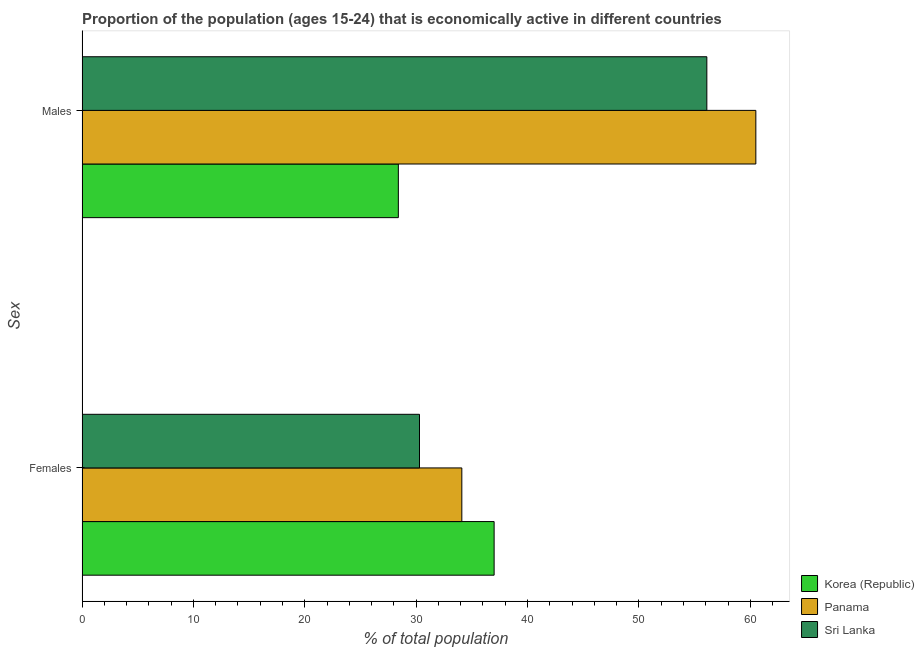How many different coloured bars are there?
Provide a short and direct response. 3. How many groups of bars are there?
Your response must be concise. 2. Are the number of bars per tick equal to the number of legend labels?
Make the answer very short. Yes. How many bars are there on the 1st tick from the top?
Offer a terse response. 3. What is the label of the 1st group of bars from the top?
Provide a succinct answer. Males. What is the percentage of economically active male population in Panama?
Your answer should be compact. 60.5. Across all countries, what is the maximum percentage of economically active female population?
Give a very brief answer. 37. Across all countries, what is the minimum percentage of economically active female population?
Your response must be concise. 30.3. In which country was the percentage of economically active male population maximum?
Keep it short and to the point. Panama. In which country was the percentage of economically active female population minimum?
Ensure brevity in your answer.  Sri Lanka. What is the total percentage of economically active female population in the graph?
Ensure brevity in your answer.  101.4. What is the difference between the percentage of economically active male population in Panama and that in Korea (Republic)?
Offer a terse response. 32.1. What is the difference between the percentage of economically active male population in Panama and the percentage of economically active female population in Sri Lanka?
Make the answer very short. 30.2. What is the average percentage of economically active female population per country?
Provide a succinct answer. 33.8. What is the difference between the percentage of economically active male population and percentage of economically active female population in Sri Lanka?
Keep it short and to the point. 25.8. What is the ratio of the percentage of economically active female population in Panama to that in Korea (Republic)?
Offer a terse response. 0.92. Is the percentage of economically active male population in Korea (Republic) less than that in Sri Lanka?
Provide a succinct answer. Yes. What does the 3rd bar from the top in Males represents?
Give a very brief answer. Korea (Republic). What does the 3rd bar from the bottom in Females represents?
Your answer should be very brief. Sri Lanka. Are the values on the major ticks of X-axis written in scientific E-notation?
Your answer should be very brief. No. Does the graph contain any zero values?
Ensure brevity in your answer.  No. How many legend labels are there?
Offer a terse response. 3. What is the title of the graph?
Your response must be concise. Proportion of the population (ages 15-24) that is economically active in different countries. Does "Vanuatu" appear as one of the legend labels in the graph?
Give a very brief answer. No. What is the label or title of the X-axis?
Give a very brief answer. % of total population. What is the label or title of the Y-axis?
Your answer should be compact. Sex. What is the % of total population in Korea (Republic) in Females?
Offer a terse response. 37. What is the % of total population of Panama in Females?
Make the answer very short. 34.1. What is the % of total population in Sri Lanka in Females?
Give a very brief answer. 30.3. What is the % of total population of Korea (Republic) in Males?
Provide a short and direct response. 28.4. What is the % of total population of Panama in Males?
Offer a terse response. 60.5. What is the % of total population of Sri Lanka in Males?
Make the answer very short. 56.1. Across all Sex, what is the maximum % of total population of Korea (Republic)?
Offer a very short reply. 37. Across all Sex, what is the maximum % of total population of Panama?
Your response must be concise. 60.5. Across all Sex, what is the maximum % of total population in Sri Lanka?
Provide a short and direct response. 56.1. Across all Sex, what is the minimum % of total population of Korea (Republic)?
Your answer should be very brief. 28.4. Across all Sex, what is the minimum % of total population of Panama?
Keep it short and to the point. 34.1. Across all Sex, what is the minimum % of total population of Sri Lanka?
Provide a succinct answer. 30.3. What is the total % of total population of Korea (Republic) in the graph?
Offer a very short reply. 65.4. What is the total % of total population in Panama in the graph?
Provide a short and direct response. 94.6. What is the total % of total population of Sri Lanka in the graph?
Ensure brevity in your answer.  86.4. What is the difference between the % of total population in Korea (Republic) in Females and that in Males?
Keep it short and to the point. 8.6. What is the difference between the % of total population of Panama in Females and that in Males?
Provide a short and direct response. -26.4. What is the difference between the % of total population in Sri Lanka in Females and that in Males?
Keep it short and to the point. -25.8. What is the difference between the % of total population in Korea (Republic) in Females and the % of total population in Panama in Males?
Offer a very short reply. -23.5. What is the difference between the % of total population of Korea (Republic) in Females and the % of total population of Sri Lanka in Males?
Offer a very short reply. -19.1. What is the difference between the % of total population in Panama in Females and the % of total population in Sri Lanka in Males?
Your answer should be very brief. -22. What is the average % of total population of Korea (Republic) per Sex?
Offer a very short reply. 32.7. What is the average % of total population of Panama per Sex?
Ensure brevity in your answer.  47.3. What is the average % of total population of Sri Lanka per Sex?
Make the answer very short. 43.2. What is the difference between the % of total population of Panama and % of total population of Sri Lanka in Females?
Your answer should be very brief. 3.8. What is the difference between the % of total population in Korea (Republic) and % of total population in Panama in Males?
Provide a short and direct response. -32.1. What is the difference between the % of total population in Korea (Republic) and % of total population in Sri Lanka in Males?
Offer a very short reply. -27.7. What is the difference between the % of total population of Panama and % of total population of Sri Lanka in Males?
Offer a very short reply. 4.4. What is the ratio of the % of total population of Korea (Republic) in Females to that in Males?
Your answer should be very brief. 1.3. What is the ratio of the % of total population of Panama in Females to that in Males?
Give a very brief answer. 0.56. What is the ratio of the % of total population of Sri Lanka in Females to that in Males?
Your response must be concise. 0.54. What is the difference between the highest and the second highest % of total population in Korea (Republic)?
Keep it short and to the point. 8.6. What is the difference between the highest and the second highest % of total population of Panama?
Keep it short and to the point. 26.4. What is the difference between the highest and the second highest % of total population of Sri Lanka?
Provide a short and direct response. 25.8. What is the difference between the highest and the lowest % of total population of Korea (Republic)?
Your response must be concise. 8.6. What is the difference between the highest and the lowest % of total population in Panama?
Provide a succinct answer. 26.4. What is the difference between the highest and the lowest % of total population of Sri Lanka?
Make the answer very short. 25.8. 